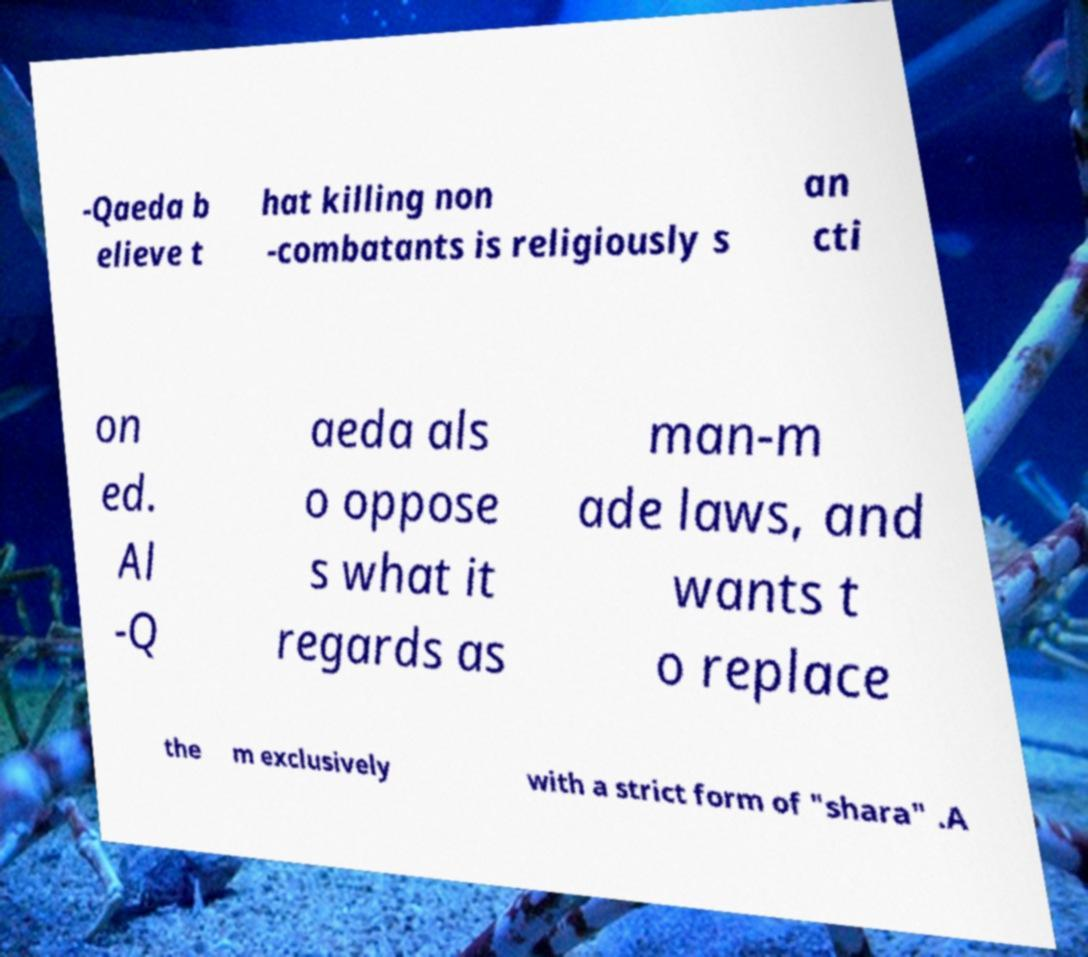What messages or text are displayed in this image? I need them in a readable, typed format. -Qaeda b elieve t hat killing non -combatants is religiously s an cti on ed. Al -Q aeda als o oppose s what it regards as man-m ade laws, and wants t o replace the m exclusively with a strict form of "shara" .A 